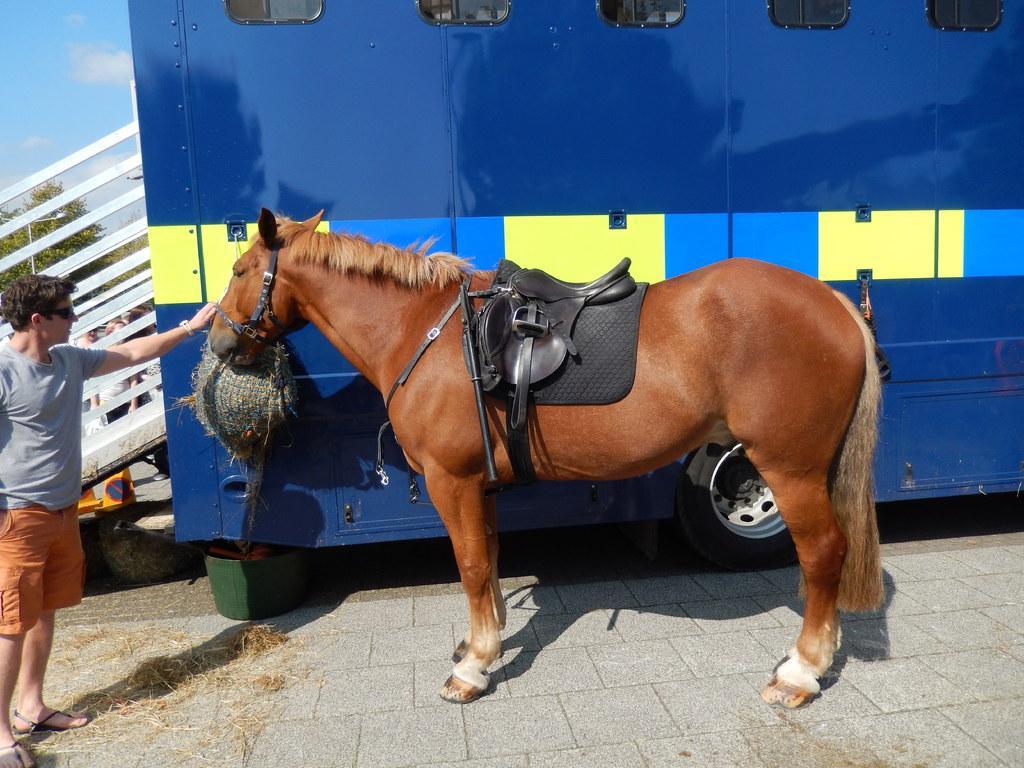Can you describe this image briefly? In this picture there is a horse standing. On the left side of the image there is a man standing. At the back there is a vehicle and there is a staircase, behind the staircase there are group of people and there are objects and there is a tree and pole. At the top there is sky and there are clouds. At the bottom there is a floor and there is grass and there is an object. 